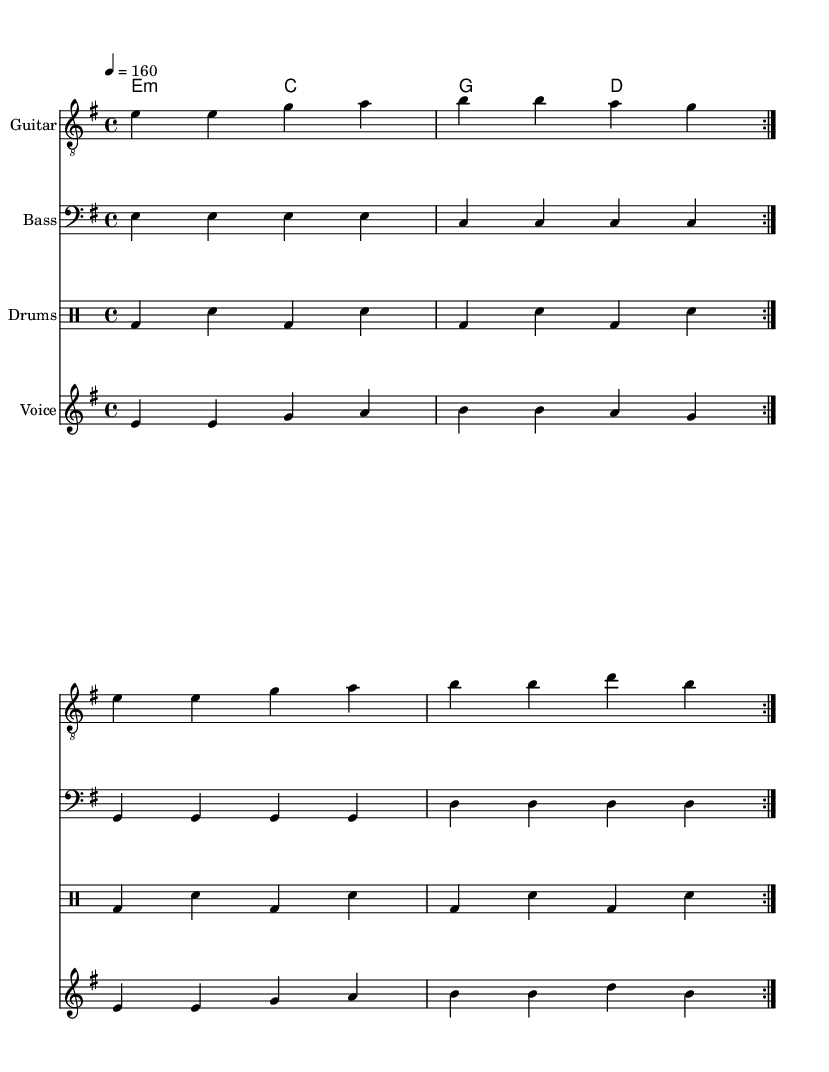What is the key signature of this music? The key signature is E minor, which has one sharp (F#). This can be determined by looking at the key signature notation at the beginning of the sheet music.
Answer: E minor What is the time signature of this music? The time signature is 4/4, which indicates four beats per measure, as shown at the beginning of the score.
Answer: 4/4 What is the tempo marking for this piece? The tempo marking is 160 beats per minute, indicated by the term "4 = 160" at the beginning of the score.
Answer: 160 How many times is the main verse repeated? The main verse is repeated twice, as denoted by the "volta 2" indication in the vocal and instrumental sections.
Answer: 2 What is the lyric theme expressed in the chorus? The chorus expresses a desire to break free from digital control, as seen in the words "Break the chains of digital control!" written in the lyric section.
Answer: Break the chains of digital control! What instrument is indicated as having a treble clef? The instrument with a treble clef is the Guitar, marked at the beginning of the staff labeled "Guitar".
Answer: Guitar What type of music genre does this piece represent? This piece represents punk music, characterized by its anti-establishment themes and aggressive sound, as reflected in the lyrics and musical composition.
Answer: Punk 